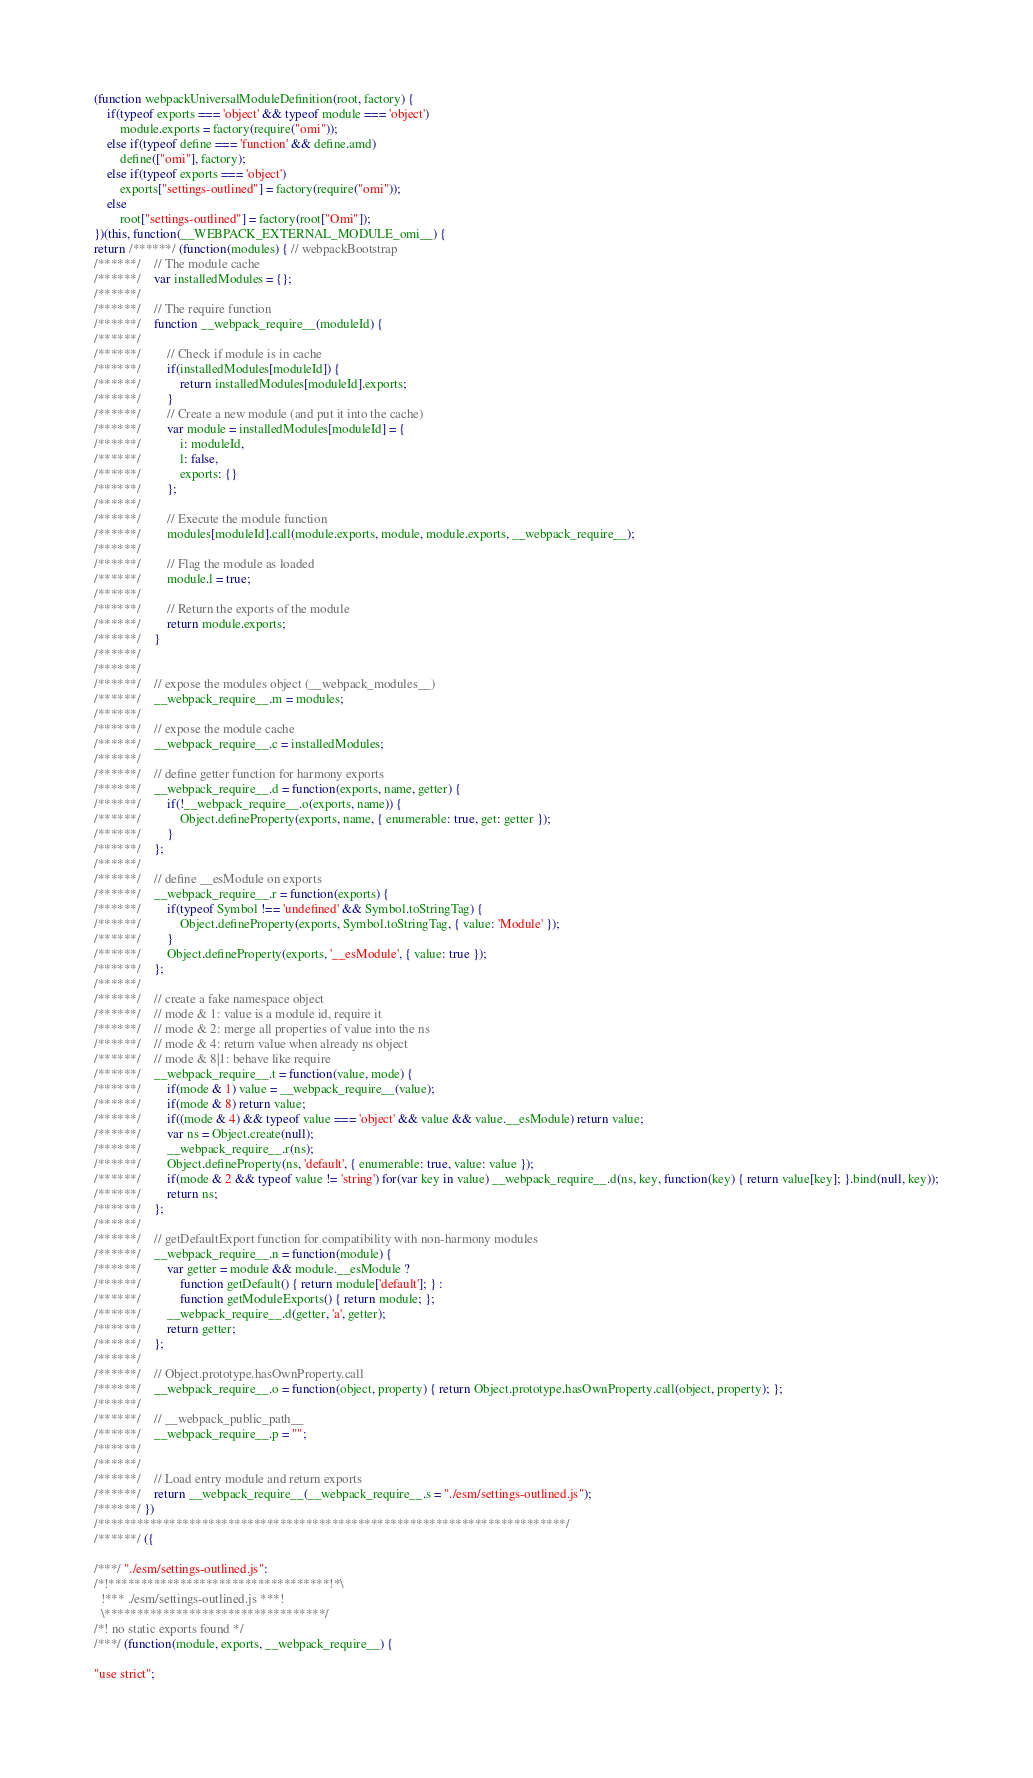Convert code to text. <code><loc_0><loc_0><loc_500><loc_500><_JavaScript_>(function webpackUniversalModuleDefinition(root, factory) {
	if(typeof exports === 'object' && typeof module === 'object')
		module.exports = factory(require("omi"));
	else if(typeof define === 'function' && define.amd)
		define(["omi"], factory);
	else if(typeof exports === 'object')
		exports["settings-outlined"] = factory(require("omi"));
	else
		root["settings-outlined"] = factory(root["Omi"]);
})(this, function(__WEBPACK_EXTERNAL_MODULE_omi__) {
return /******/ (function(modules) { // webpackBootstrap
/******/ 	// The module cache
/******/ 	var installedModules = {};
/******/
/******/ 	// The require function
/******/ 	function __webpack_require__(moduleId) {
/******/
/******/ 		// Check if module is in cache
/******/ 		if(installedModules[moduleId]) {
/******/ 			return installedModules[moduleId].exports;
/******/ 		}
/******/ 		// Create a new module (and put it into the cache)
/******/ 		var module = installedModules[moduleId] = {
/******/ 			i: moduleId,
/******/ 			l: false,
/******/ 			exports: {}
/******/ 		};
/******/
/******/ 		// Execute the module function
/******/ 		modules[moduleId].call(module.exports, module, module.exports, __webpack_require__);
/******/
/******/ 		// Flag the module as loaded
/******/ 		module.l = true;
/******/
/******/ 		// Return the exports of the module
/******/ 		return module.exports;
/******/ 	}
/******/
/******/
/******/ 	// expose the modules object (__webpack_modules__)
/******/ 	__webpack_require__.m = modules;
/******/
/******/ 	// expose the module cache
/******/ 	__webpack_require__.c = installedModules;
/******/
/******/ 	// define getter function for harmony exports
/******/ 	__webpack_require__.d = function(exports, name, getter) {
/******/ 		if(!__webpack_require__.o(exports, name)) {
/******/ 			Object.defineProperty(exports, name, { enumerable: true, get: getter });
/******/ 		}
/******/ 	};
/******/
/******/ 	// define __esModule on exports
/******/ 	__webpack_require__.r = function(exports) {
/******/ 		if(typeof Symbol !== 'undefined' && Symbol.toStringTag) {
/******/ 			Object.defineProperty(exports, Symbol.toStringTag, { value: 'Module' });
/******/ 		}
/******/ 		Object.defineProperty(exports, '__esModule', { value: true });
/******/ 	};
/******/
/******/ 	// create a fake namespace object
/******/ 	// mode & 1: value is a module id, require it
/******/ 	// mode & 2: merge all properties of value into the ns
/******/ 	// mode & 4: return value when already ns object
/******/ 	// mode & 8|1: behave like require
/******/ 	__webpack_require__.t = function(value, mode) {
/******/ 		if(mode & 1) value = __webpack_require__(value);
/******/ 		if(mode & 8) return value;
/******/ 		if((mode & 4) && typeof value === 'object' && value && value.__esModule) return value;
/******/ 		var ns = Object.create(null);
/******/ 		__webpack_require__.r(ns);
/******/ 		Object.defineProperty(ns, 'default', { enumerable: true, value: value });
/******/ 		if(mode & 2 && typeof value != 'string') for(var key in value) __webpack_require__.d(ns, key, function(key) { return value[key]; }.bind(null, key));
/******/ 		return ns;
/******/ 	};
/******/
/******/ 	// getDefaultExport function for compatibility with non-harmony modules
/******/ 	__webpack_require__.n = function(module) {
/******/ 		var getter = module && module.__esModule ?
/******/ 			function getDefault() { return module['default']; } :
/******/ 			function getModuleExports() { return module; };
/******/ 		__webpack_require__.d(getter, 'a', getter);
/******/ 		return getter;
/******/ 	};
/******/
/******/ 	// Object.prototype.hasOwnProperty.call
/******/ 	__webpack_require__.o = function(object, property) { return Object.prototype.hasOwnProperty.call(object, property); };
/******/
/******/ 	// __webpack_public_path__
/******/ 	__webpack_require__.p = "";
/******/
/******/
/******/ 	// Load entry module and return exports
/******/ 	return __webpack_require__(__webpack_require__.s = "./esm/settings-outlined.js");
/******/ })
/************************************************************************/
/******/ ({

/***/ "./esm/settings-outlined.js":
/*!**********************************!*\
  !*** ./esm/settings-outlined.js ***!
  \**********************************/
/*! no static exports found */
/***/ (function(module, exports, __webpack_require__) {

"use strict";</code> 